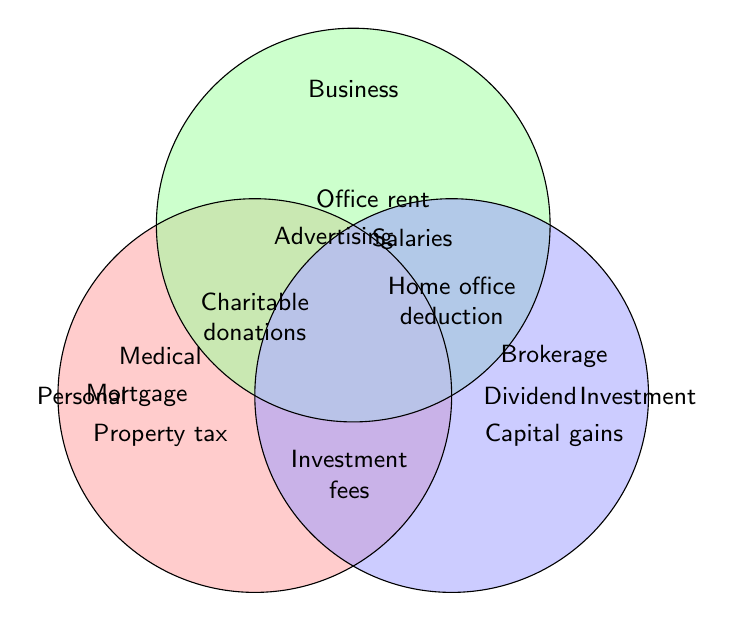What types of tax deductions are classified under Personal? The figure shows the 'Personal' circle containing 'Mortgage', 'Property tax', 'Medical', 'Charitable donations', and 'Student loan interest'.
Answer: Mortgage, Property tax, Medical, Charitable donations, Student loan interest Which tax deduction types fall under Business? The 'Business' circle has deductions labeled inside it: 'Office rent', 'Salaries', 'Advertising', and 'Home office deduction'.
Answer: Office rent, Salaries, Advertising, Home office deduction What deductions are specifically for Investment purposes? The 'Investment' circle contains 'Dividend', 'Capital gains', and 'Brokerage'.
Answer: Dividend, Capital gains, Brokerage Which deductions overlap between Personal and Business categories? Inside the overlapping area between 'Personal' and 'Business', the figure indicates 'Charitable donations'.
Answer: Charitable donations Which category or categories does 'Salaries' fall into? 'Salaries' is within the 'Business' circle showing it falls only under Business.
Answer: Business Are there any deductions that overlap between all three categories (Personal, Business, Investment)? The center area where all three circles overlap contains 'Investment fees'.
Answer: Investment fees Which deduction has the widest overlap (appears in most categories)? 'Investment fees' appears where all three circles overlap, so it is part of Personal, Business, and Investment.
Answer: Investment fees Between Personal and Investment, which has more unique deductions? Personal has more unique deductions because this category contains five unique deductions compared to Investment's three.
Answer: Personal Do any deductions overlap between Business and Investment categories? The overlap area of 'Business' and 'Investment' contains 'Home office deduction'.
Answer: Home office deduction 